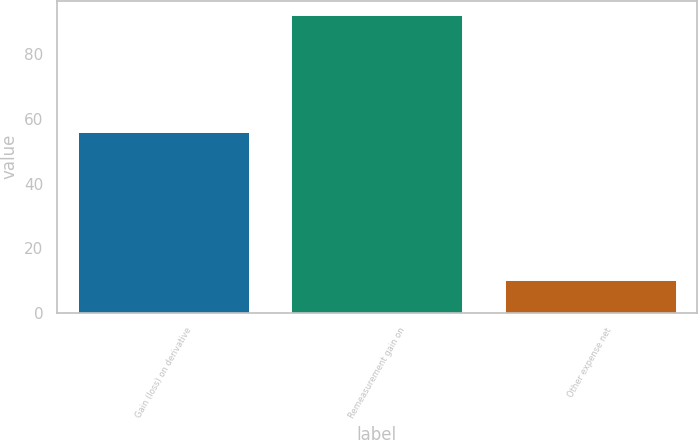Convert chart to OTSL. <chart><loc_0><loc_0><loc_500><loc_500><bar_chart><fcel>Gain (loss) on derivative<fcel>Remeasurement gain on<fcel>Other expense net<nl><fcel>56<fcel>92<fcel>10<nl></chart> 